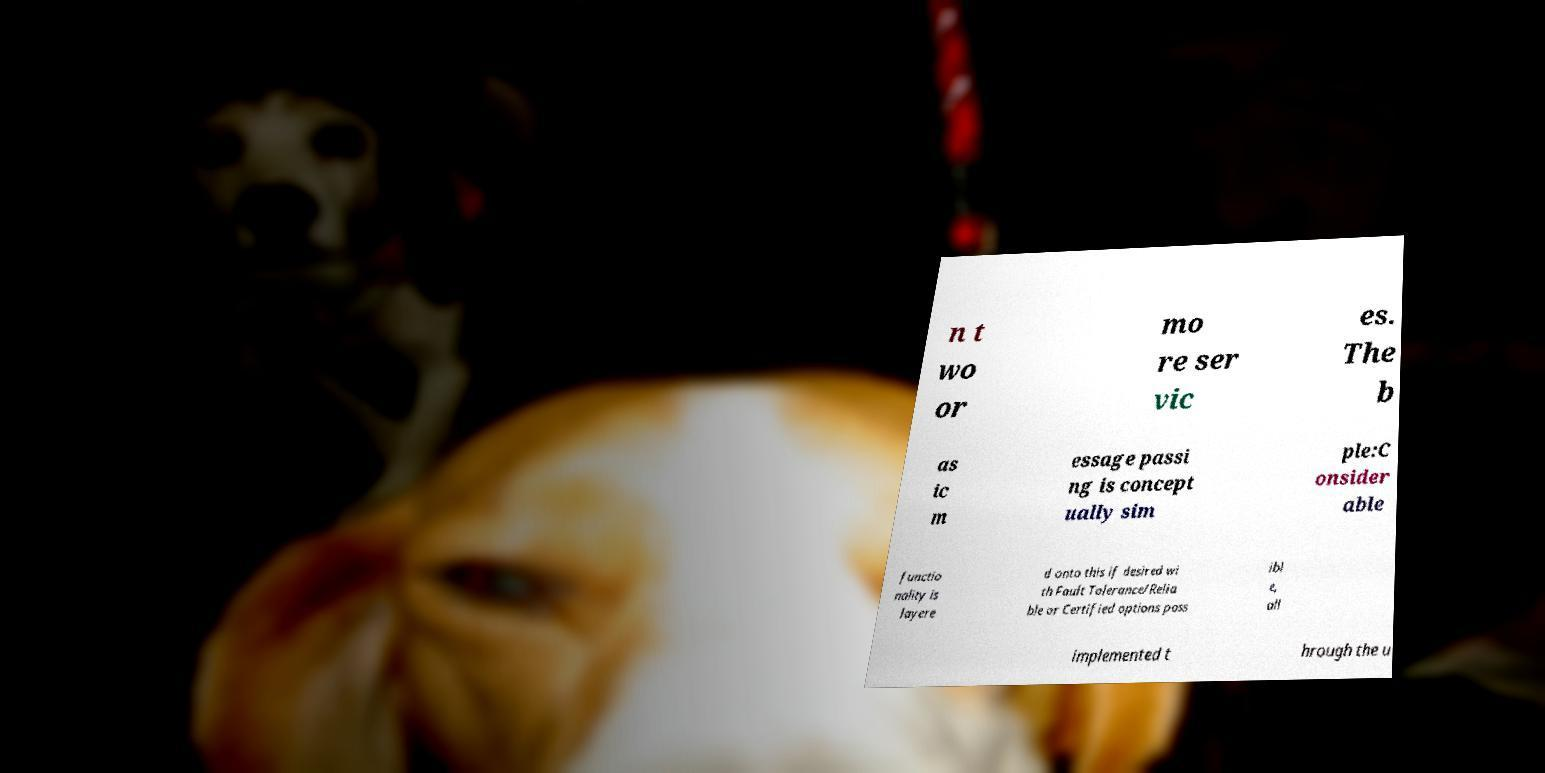There's text embedded in this image that I need extracted. Can you transcribe it verbatim? n t wo or mo re ser vic es. The b as ic m essage passi ng is concept ually sim ple:C onsider able functio nality is layere d onto this if desired wi th Fault Tolerance/Relia ble or Certified options poss ibl e, all implemented t hrough the u 